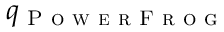Convert formula to latex. <formula><loc_0><loc_0><loc_500><loc_500>q _ { P o w e r F r o g }</formula> 